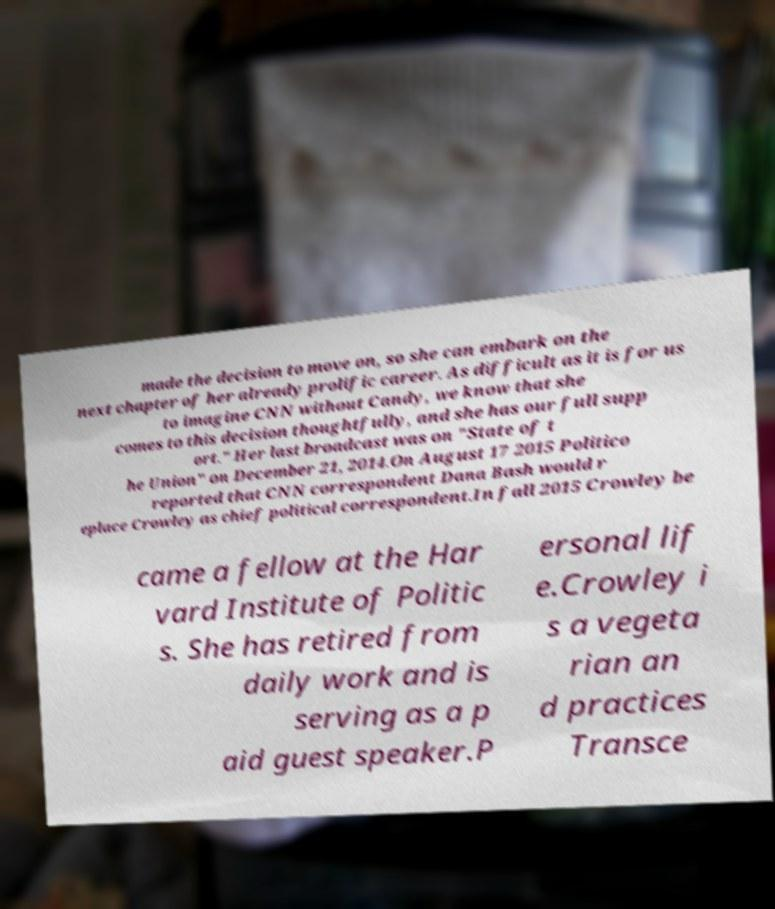There's text embedded in this image that I need extracted. Can you transcribe it verbatim? made the decision to move on, so she can embark on the next chapter of her already prolific career. As difficult as it is for us to imagine CNN without Candy, we know that she comes to this decision thoughtfully, and she has our full supp ort." Her last broadcast was on "State of t he Union" on December 21, 2014.On August 17 2015 Politico reported that CNN correspondent Dana Bash would r eplace Crowley as chief political correspondent.In fall 2015 Crowley be came a fellow at the Har vard Institute of Politic s. She has retired from daily work and is serving as a p aid guest speaker.P ersonal lif e.Crowley i s a vegeta rian an d practices Transce 